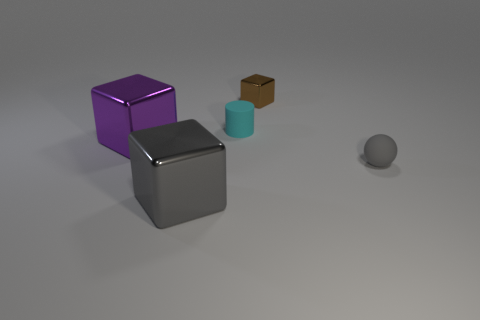Add 3 tiny brown cylinders. How many objects exist? 8 Subtract all spheres. How many objects are left? 4 Add 2 small yellow shiny spheres. How many small yellow shiny spheres exist? 2 Subtract 0 blue cylinders. How many objects are left? 5 Subtract all small shiny spheres. Subtract all metal blocks. How many objects are left? 2 Add 5 purple metal objects. How many purple metal objects are left? 6 